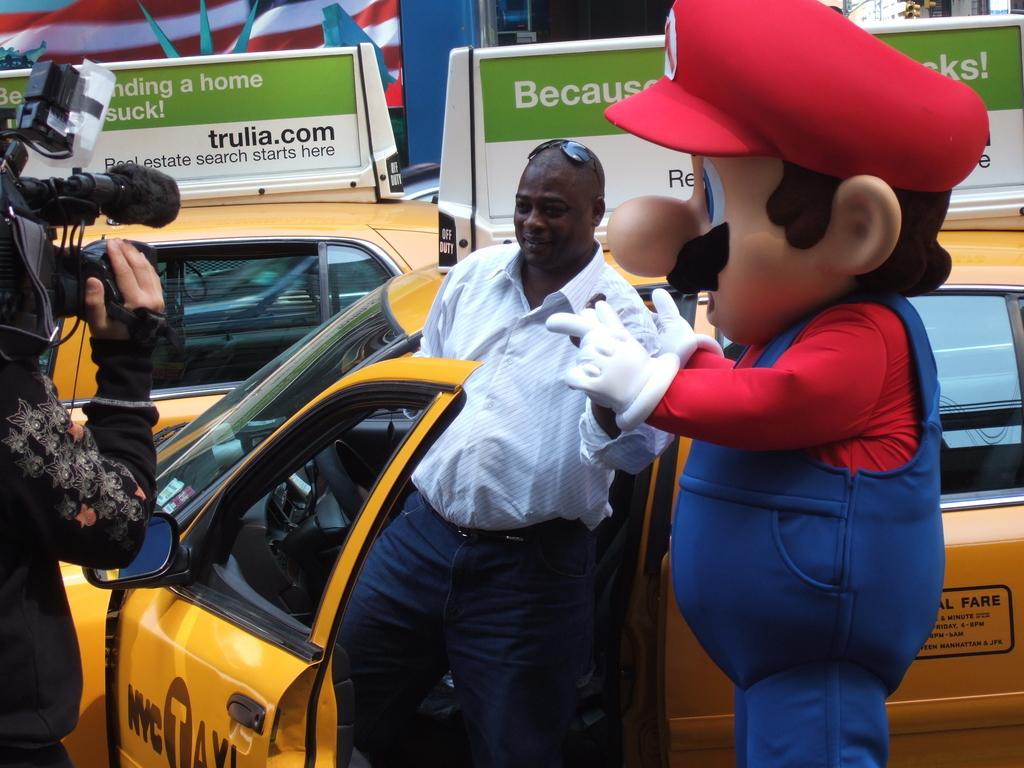Provide a one-sentence caption for the provided image. A taxi driver is standing outside his door while a camera operator is filming him beside a man dressed up as Mario. 